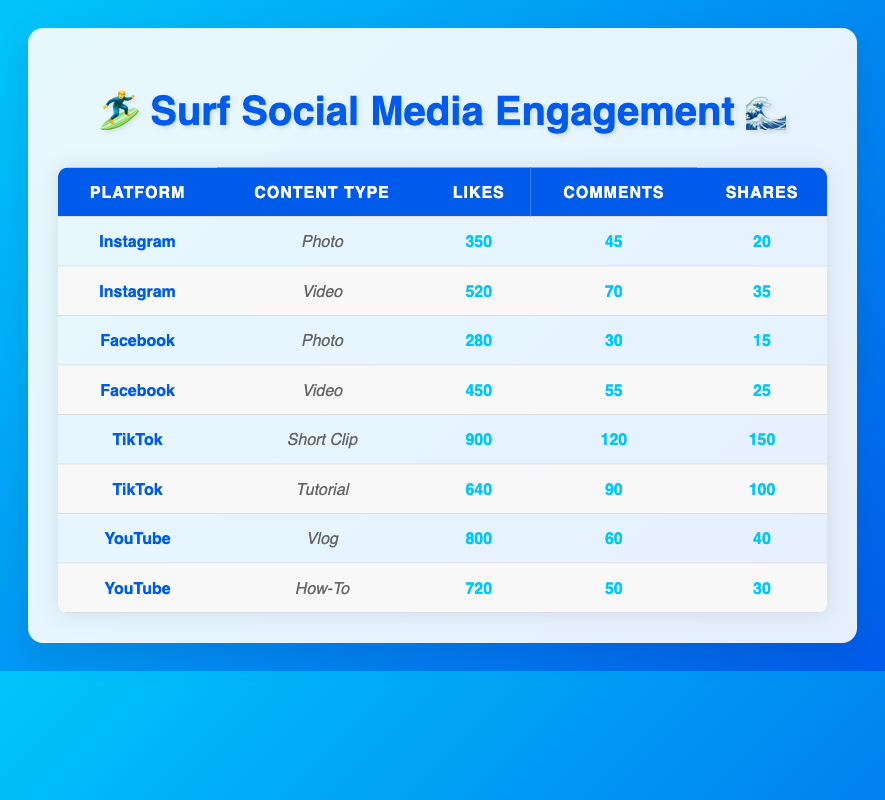What's the total number of likes for Instagram posts? For Instagram, the likes for photos is 350 and for videos is 520. Adding these gives 350 + 520 = 870.
Answer: 870 Which content type has the highest number of shares on TikTok? On TikTok, the short clip has 150 shares while the tutorial has 100 shares. Therefore, the short clip has the highest number of shares.
Answer: Short Clip Is the average number of comments for Facebook posts greater than 40? On Facebook, there are two posts: the photo has 30 comments and the video has 55 comments. The average is (30 + 55) / 2 = 42.5, which is greater than 40.
Answer: Yes What is the difference in likes between the most liked video on Instagram and the most liked video on Facebook? The most liked video on Instagram has 520 likes and the most liked video on Facebook has 450 likes. The difference is 520 - 450 = 70.
Answer: 70 Which platform has the highest total engagement (likes + comments + shares) for video content? For Instagram video: 520 + 70 + 35 = 625; For Facebook video: 450 + 55 + 25 = 530; For YouTube: No video data is listed specifically, but the highest is TikTok video (640 + 90 + 100 = 830). Therefore, TikTok has the highest total engagement in video content.
Answer: TikTok Is there a content type with more likes than 900 on TikTok? The short clip has 900 likes, but the tutorial has only 640 likes. Therefore, there is no content type on TikTok with more than 900 likes.
Answer: No Which platform's photo content type has the least likes? On Facebook, the photo content type has 280 likes, while Instagram has 350 likes. Therefore, Facebook's photo content type has the least likes.
Answer: Facebook What percentage of shares does TikTok's short clip represent of the total shares across all platforms and content types? Total shares = 20 (Instagram Photo) + 35 (Instagram Video) + 15 (Facebook Photo) + 25 (Facebook Video) + 150 (TikTok Short Clip) + 100 (TikTok Tutorial) + 40 (YouTube Vlog) + 30 (YouTube How-To) = 415. Shares for TikTok short clip = 150. The percentage is (150 / 415) * 100 ≈ 36.14%.
Answer: 36.14% 